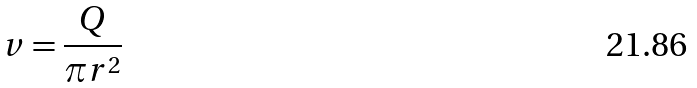<formula> <loc_0><loc_0><loc_500><loc_500>v = \frac { Q } { \pi r ^ { 2 } }</formula> 